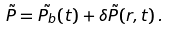<formula> <loc_0><loc_0><loc_500><loc_500>\tilde { P } = \tilde { P _ { b } } ( t ) + \delta \tilde { P } ( r , t ) \, .</formula> 